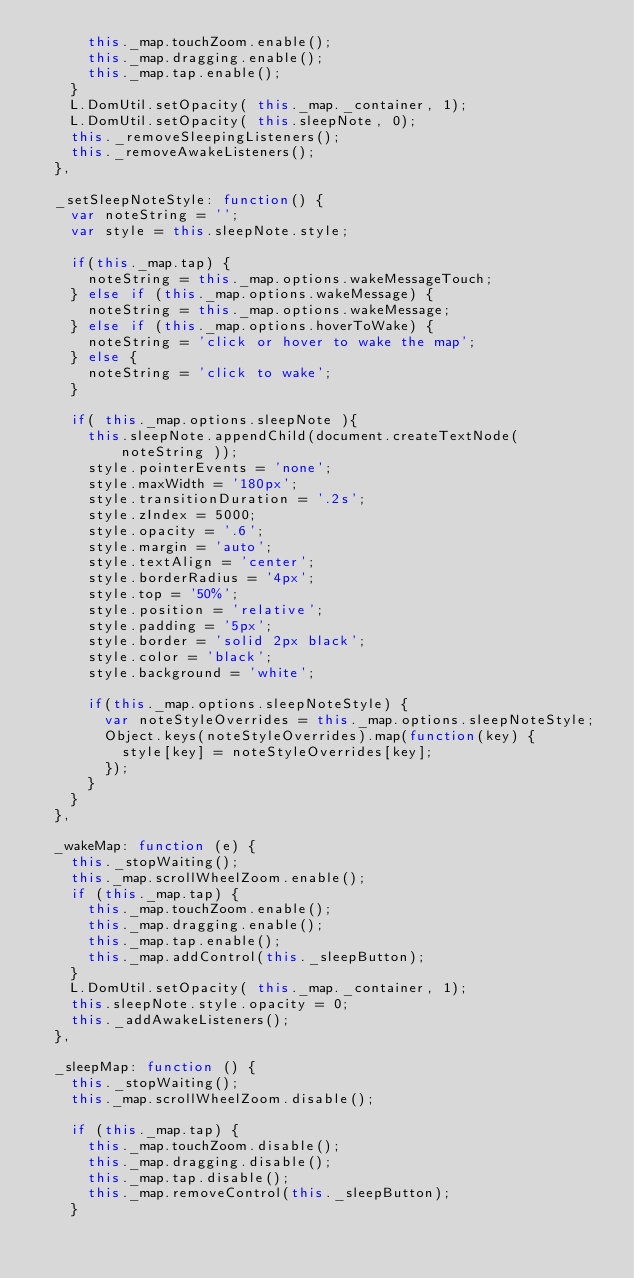<code> <loc_0><loc_0><loc_500><loc_500><_JavaScript_>      this._map.touchZoom.enable();
      this._map.dragging.enable();
      this._map.tap.enable();
    }
    L.DomUtil.setOpacity( this._map._container, 1);
    L.DomUtil.setOpacity( this.sleepNote, 0);
    this._removeSleepingListeners();
    this._removeAwakeListeners();
  },

  _setSleepNoteStyle: function() {
    var noteString = '';
    var style = this.sleepNote.style;

    if(this._map.tap) {
      noteString = this._map.options.wakeMessageTouch;
    } else if (this._map.options.wakeMessage) {
      noteString = this._map.options.wakeMessage;
    } else if (this._map.options.hoverToWake) {
      noteString = 'click or hover to wake the map';
    } else {
      noteString = 'click to wake';
    }

    if( this._map.options.sleepNote ){
      this.sleepNote.appendChild(document.createTextNode( noteString ));
      style.pointerEvents = 'none';
      style.maxWidth = '180px';
      style.transitionDuration = '.2s';
      style.zIndex = 5000;
      style.opacity = '.6';
      style.margin = 'auto';
      style.textAlign = 'center';
      style.borderRadius = '4px';
      style.top = '50%';
      style.position = 'relative';
      style.padding = '5px';
      style.border = 'solid 2px black';
      style.color = 'black';
      style.background = 'white';

      if(this._map.options.sleepNoteStyle) {
        var noteStyleOverrides = this._map.options.sleepNoteStyle;
        Object.keys(noteStyleOverrides).map(function(key) {
          style[key] = noteStyleOverrides[key];
        });
      }
    }
  },

  _wakeMap: function (e) {
    this._stopWaiting();
    this._map.scrollWheelZoom.enable();
    if (this._map.tap) {
      this._map.touchZoom.enable();
      this._map.dragging.enable();
      this._map.tap.enable();
      this._map.addControl(this._sleepButton);
    }
    L.DomUtil.setOpacity( this._map._container, 1);
    this.sleepNote.style.opacity = 0;
    this._addAwakeListeners();
  },

  _sleepMap: function () {
    this._stopWaiting();
    this._map.scrollWheelZoom.disable();

    if (this._map.tap) {
      this._map.touchZoom.disable();
      this._map.dragging.disable();
      this._map.tap.disable();
      this._map.removeControl(this._sleepButton);
    }
</code> 